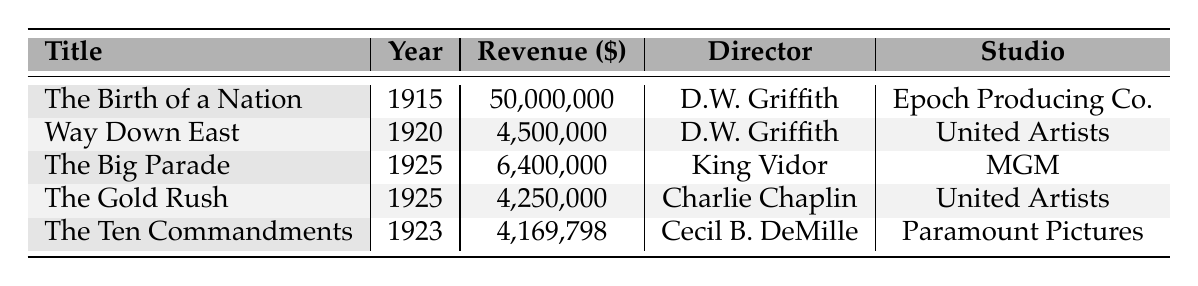What is the highest box office revenue among the listed films? The table shows the revenue for each film. The highest revenue is for "The Birth of a Nation" at $50,000,000.
Answer: $50,000,000 Who directed "The Gold Rush"? The table indicates the director for each film. "The Gold Rush" was directed by Charlie Chaplin.
Answer: Charlie Chaplin How much revenue did "The Ten Commandments" earn? The revenue for "The Ten Commandments" is clearly stated in the table as $4,169,798.
Answer: $4,169,798 What is the total box office revenue for the films released in 1925? From the table, we have "The Big Parade" ($6,400,000) and "The Gold Rush" ($4,250,000). Adding these two gives $6,400,000 + $4,250,000 = $10,650,000.
Answer: $10,650,000 How many films were directed by D.W. Griffith? The table lists two films directed by D.W. Griffith: "The Birth of a Nation" and "Way Down East." Therefore, the total is 2 films.
Answer: 2 Is "The Big Parade" the only film released in 1925? The table shows two films released in 1925 - "The Big Parade" and "The Gold Rush." Therefore, the statement is false.
Answer: No What is the average box office revenue of the films listed? The revenues are $50,000,000, $4,500,000, $6,400,000, $4,250,000, and $4,169,798. Summing these yields $69,319,798. Dividing by 5 gives an average of $13,863,959.6.
Answer: $13,863,959.6 Which film had a lower revenue, "Way Down East" or "The Gold Rush"? The table shows "Way Down East" with $4,500,000 and "The Gold Rush" with $4,250,000. Since $4,250,000 < $4,500,000, "The Gold Rush" had the lower revenue.
Answer: The Gold Rush Which studio produced the highest-grossing film? According to the table, the highest-grossing film is "The Birth of a Nation," produced by Epoch Producing Co. Thus, the studio is Epoch Producing Co.
Answer: Epoch Producing Co In which year did "The Ten Commandments" release and how much did it earn? The table indicates that "The Ten Commandments" was released in 1923 and earned $4,169,798.
Answer: 1923, $4,169,798 